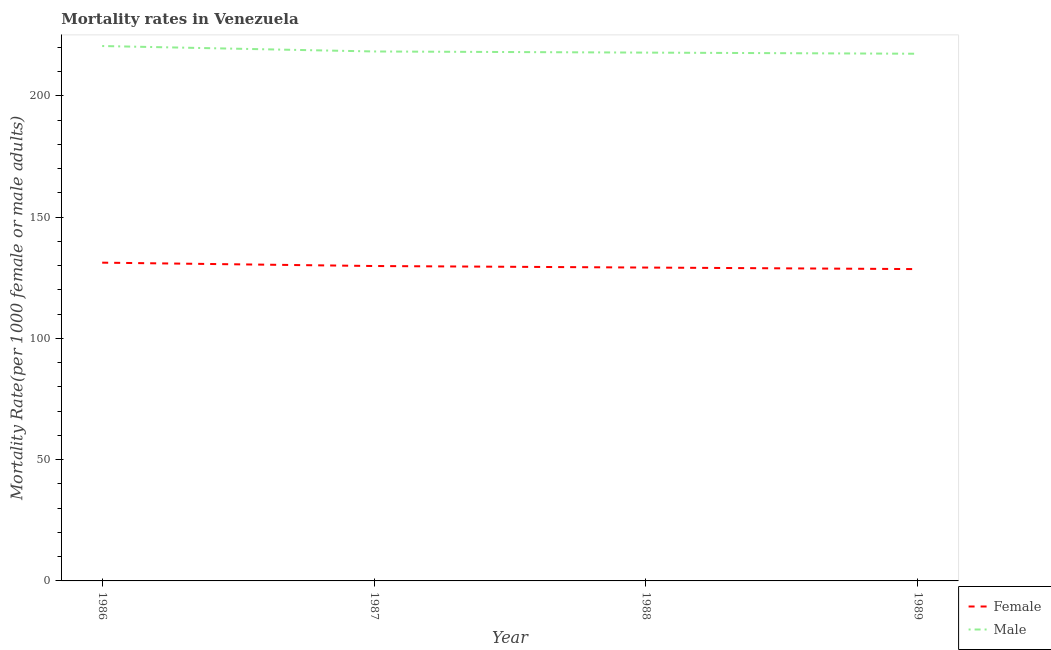How many different coloured lines are there?
Offer a very short reply. 2. Is the number of lines equal to the number of legend labels?
Your answer should be very brief. Yes. What is the male mortality rate in 1988?
Keep it short and to the point. 217.8. Across all years, what is the maximum female mortality rate?
Your answer should be very brief. 131.21. Across all years, what is the minimum male mortality rate?
Keep it short and to the point. 217.33. In which year was the female mortality rate maximum?
Give a very brief answer. 1986. What is the total female mortality rate in the graph?
Keep it short and to the point. 518.77. What is the difference between the female mortality rate in 1987 and that in 1988?
Give a very brief answer. 0.64. What is the difference between the male mortality rate in 1988 and the female mortality rate in 1986?
Provide a short and direct response. 86.6. What is the average female mortality rate per year?
Ensure brevity in your answer.  129.69. In the year 1987, what is the difference between the female mortality rate and male mortality rate?
Offer a very short reply. -88.45. In how many years, is the female mortality rate greater than 200?
Your answer should be very brief. 0. What is the ratio of the male mortality rate in 1987 to that in 1988?
Give a very brief answer. 1. Is the male mortality rate in 1986 less than that in 1987?
Keep it short and to the point. No. What is the difference between the highest and the second highest female mortality rate?
Offer a very short reply. 1.38. What is the difference between the highest and the lowest male mortality rate?
Ensure brevity in your answer.  3.18. In how many years, is the male mortality rate greater than the average male mortality rate taken over all years?
Keep it short and to the point. 1. Is the male mortality rate strictly greater than the female mortality rate over the years?
Give a very brief answer. Yes. Is the male mortality rate strictly less than the female mortality rate over the years?
Offer a very short reply. No. How many lines are there?
Your response must be concise. 2. What is the difference between two consecutive major ticks on the Y-axis?
Your response must be concise. 50. Are the values on the major ticks of Y-axis written in scientific E-notation?
Provide a short and direct response. No. Does the graph contain grids?
Provide a succinct answer. No. What is the title of the graph?
Offer a terse response. Mortality rates in Venezuela. What is the label or title of the X-axis?
Provide a short and direct response. Year. What is the label or title of the Y-axis?
Your answer should be compact. Mortality Rate(per 1000 female or male adults). What is the Mortality Rate(per 1000 female or male adults) in Female in 1986?
Your response must be concise. 131.21. What is the Mortality Rate(per 1000 female or male adults) in Male in 1986?
Make the answer very short. 220.51. What is the Mortality Rate(per 1000 female or male adults) of Female in 1987?
Keep it short and to the point. 129.82. What is the Mortality Rate(per 1000 female or male adults) in Male in 1987?
Your response must be concise. 218.27. What is the Mortality Rate(per 1000 female or male adults) of Female in 1988?
Make the answer very short. 129.19. What is the Mortality Rate(per 1000 female or male adults) in Male in 1988?
Keep it short and to the point. 217.8. What is the Mortality Rate(per 1000 female or male adults) in Female in 1989?
Your response must be concise. 128.55. What is the Mortality Rate(per 1000 female or male adults) in Male in 1989?
Your answer should be very brief. 217.33. Across all years, what is the maximum Mortality Rate(per 1000 female or male adults) in Female?
Your response must be concise. 131.21. Across all years, what is the maximum Mortality Rate(per 1000 female or male adults) in Male?
Ensure brevity in your answer.  220.51. Across all years, what is the minimum Mortality Rate(per 1000 female or male adults) in Female?
Ensure brevity in your answer.  128.55. Across all years, what is the minimum Mortality Rate(per 1000 female or male adults) in Male?
Your answer should be very brief. 217.33. What is the total Mortality Rate(per 1000 female or male adults) in Female in the graph?
Your answer should be compact. 518.77. What is the total Mortality Rate(per 1000 female or male adults) of Male in the graph?
Offer a very short reply. 873.93. What is the difference between the Mortality Rate(per 1000 female or male adults) of Female in 1986 and that in 1987?
Your answer should be very brief. 1.38. What is the difference between the Mortality Rate(per 1000 female or male adults) of Male in 1986 and that in 1987?
Your answer should be very brief. 2.24. What is the difference between the Mortality Rate(per 1000 female or male adults) of Female in 1986 and that in 1988?
Your answer should be compact. 2.02. What is the difference between the Mortality Rate(per 1000 female or male adults) of Male in 1986 and that in 1988?
Your response must be concise. 2.71. What is the difference between the Mortality Rate(per 1000 female or male adults) in Female in 1986 and that in 1989?
Your response must be concise. 2.65. What is the difference between the Mortality Rate(per 1000 female or male adults) of Male in 1986 and that in 1989?
Your answer should be very brief. 3.18. What is the difference between the Mortality Rate(per 1000 female or male adults) in Female in 1987 and that in 1988?
Make the answer very short. 0.64. What is the difference between the Mortality Rate(per 1000 female or male adults) in Male in 1987 and that in 1988?
Provide a short and direct response. 0.47. What is the difference between the Mortality Rate(per 1000 female or male adults) of Female in 1987 and that in 1989?
Provide a succinct answer. 1.27. What is the difference between the Mortality Rate(per 1000 female or male adults) of Male in 1987 and that in 1989?
Make the answer very short. 0.94. What is the difference between the Mortality Rate(per 1000 female or male adults) of Female in 1988 and that in 1989?
Make the answer very short. 0.64. What is the difference between the Mortality Rate(per 1000 female or male adults) in Male in 1988 and that in 1989?
Make the answer very short. 0.47. What is the difference between the Mortality Rate(per 1000 female or male adults) of Female in 1986 and the Mortality Rate(per 1000 female or male adults) of Male in 1987?
Keep it short and to the point. -87.07. What is the difference between the Mortality Rate(per 1000 female or male adults) of Female in 1986 and the Mortality Rate(per 1000 female or male adults) of Male in 1988?
Ensure brevity in your answer.  -86.6. What is the difference between the Mortality Rate(per 1000 female or male adults) in Female in 1986 and the Mortality Rate(per 1000 female or male adults) in Male in 1989?
Offer a very short reply. -86.13. What is the difference between the Mortality Rate(per 1000 female or male adults) in Female in 1987 and the Mortality Rate(per 1000 female or male adults) in Male in 1988?
Offer a terse response. -87.98. What is the difference between the Mortality Rate(per 1000 female or male adults) in Female in 1987 and the Mortality Rate(per 1000 female or male adults) in Male in 1989?
Make the answer very short. -87.51. What is the difference between the Mortality Rate(per 1000 female or male adults) of Female in 1988 and the Mortality Rate(per 1000 female or male adults) of Male in 1989?
Make the answer very short. -88.15. What is the average Mortality Rate(per 1000 female or male adults) in Female per year?
Make the answer very short. 129.69. What is the average Mortality Rate(per 1000 female or male adults) of Male per year?
Ensure brevity in your answer.  218.48. In the year 1986, what is the difference between the Mortality Rate(per 1000 female or male adults) of Female and Mortality Rate(per 1000 female or male adults) of Male?
Offer a terse response. -89.31. In the year 1987, what is the difference between the Mortality Rate(per 1000 female or male adults) in Female and Mortality Rate(per 1000 female or male adults) in Male?
Provide a short and direct response. -88.45. In the year 1988, what is the difference between the Mortality Rate(per 1000 female or male adults) of Female and Mortality Rate(per 1000 female or male adults) of Male?
Provide a short and direct response. -88.62. In the year 1989, what is the difference between the Mortality Rate(per 1000 female or male adults) of Female and Mortality Rate(per 1000 female or male adults) of Male?
Your response must be concise. -88.78. What is the ratio of the Mortality Rate(per 1000 female or male adults) in Female in 1986 to that in 1987?
Give a very brief answer. 1.01. What is the ratio of the Mortality Rate(per 1000 female or male adults) of Male in 1986 to that in 1987?
Your response must be concise. 1.01. What is the ratio of the Mortality Rate(per 1000 female or male adults) in Female in 1986 to that in 1988?
Offer a very short reply. 1.02. What is the ratio of the Mortality Rate(per 1000 female or male adults) of Male in 1986 to that in 1988?
Keep it short and to the point. 1.01. What is the ratio of the Mortality Rate(per 1000 female or male adults) in Female in 1986 to that in 1989?
Your response must be concise. 1.02. What is the ratio of the Mortality Rate(per 1000 female or male adults) of Male in 1986 to that in 1989?
Your answer should be very brief. 1.01. What is the ratio of the Mortality Rate(per 1000 female or male adults) in Female in 1987 to that in 1988?
Give a very brief answer. 1. What is the ratio of the Mortality Rate(per 1000 female or male adults) in Male in 1987 to that in 1988?
Offer a terse response. 1. What is the ratio of the Mortality Rate(per 1000 female or male adults) of Female in 1987 to that in 1989?
Provide a short and direct response. 1.01. What is the difference between the highest and the second highest Mortality Rate(per 1000 female or male adults) in Female?
Offer a very short reply. 1.38. What is the difference between the highest and the second highest Mortality Rate(per 1000 female or male adults) of Male?
Make the answer very short. 2.24. What is the difference between the highest and the lowest Mortality Rate(per 1000 female or male adults) in Female?
Offer a terse response. 2.65. What is the difference between the highest and the lowest Mortality Rate(per 1000 female or male adults) of Male?
Provide a short and direct response. 3.18. 